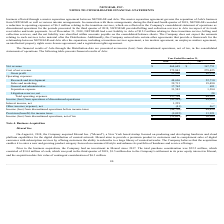According to Netgear's financial document, How many percent of outstanding shares of Arlo common stock does NETGEAR hold before the distribution? Based on the financial document, the answer is 84.2%. Also, What was the net liability to Arlo in 2018? According to the financial document, $12.2 million. The relevant text states: "r 31, 2018, NETGEAR had a net liability to Arlo of $12.2 million relating to these transition service, billing and collection services, and the net liability was cla r 31, 2018, NETGEAR had a net liab..." Also, What was Arlo's initial public offering share price? Based on the financial document, the answer is 16. Additionally, Which year has a lower total operating expense? According to the financial document, 2017. The relevant text states: "2018 2017..." Also, can you calculate: What was the percentage change in net revenue from 2017 to 2018? To answer this question, I need to perform calculations using the financial data. The calculation is: ($464,649 - $367,751)/$367,751 , which equals 26.35 (percentage). This is based on the information: "Net revenue $ 464,649 $ 367,751 Net revenue $ 464,649 $ 367,751..." The key data points involved are: 367,751, 464,649. Also, How many components does the operating expenses consist of? Counting the relevant items in the document: Research and development ,  Sales and marketing ,  General and administrative ,  Separation expense ,  Litigation reserves, net, I find 5 instances. The key data points involved are: General and administrative, Litigation reserves, net, Research and development. 